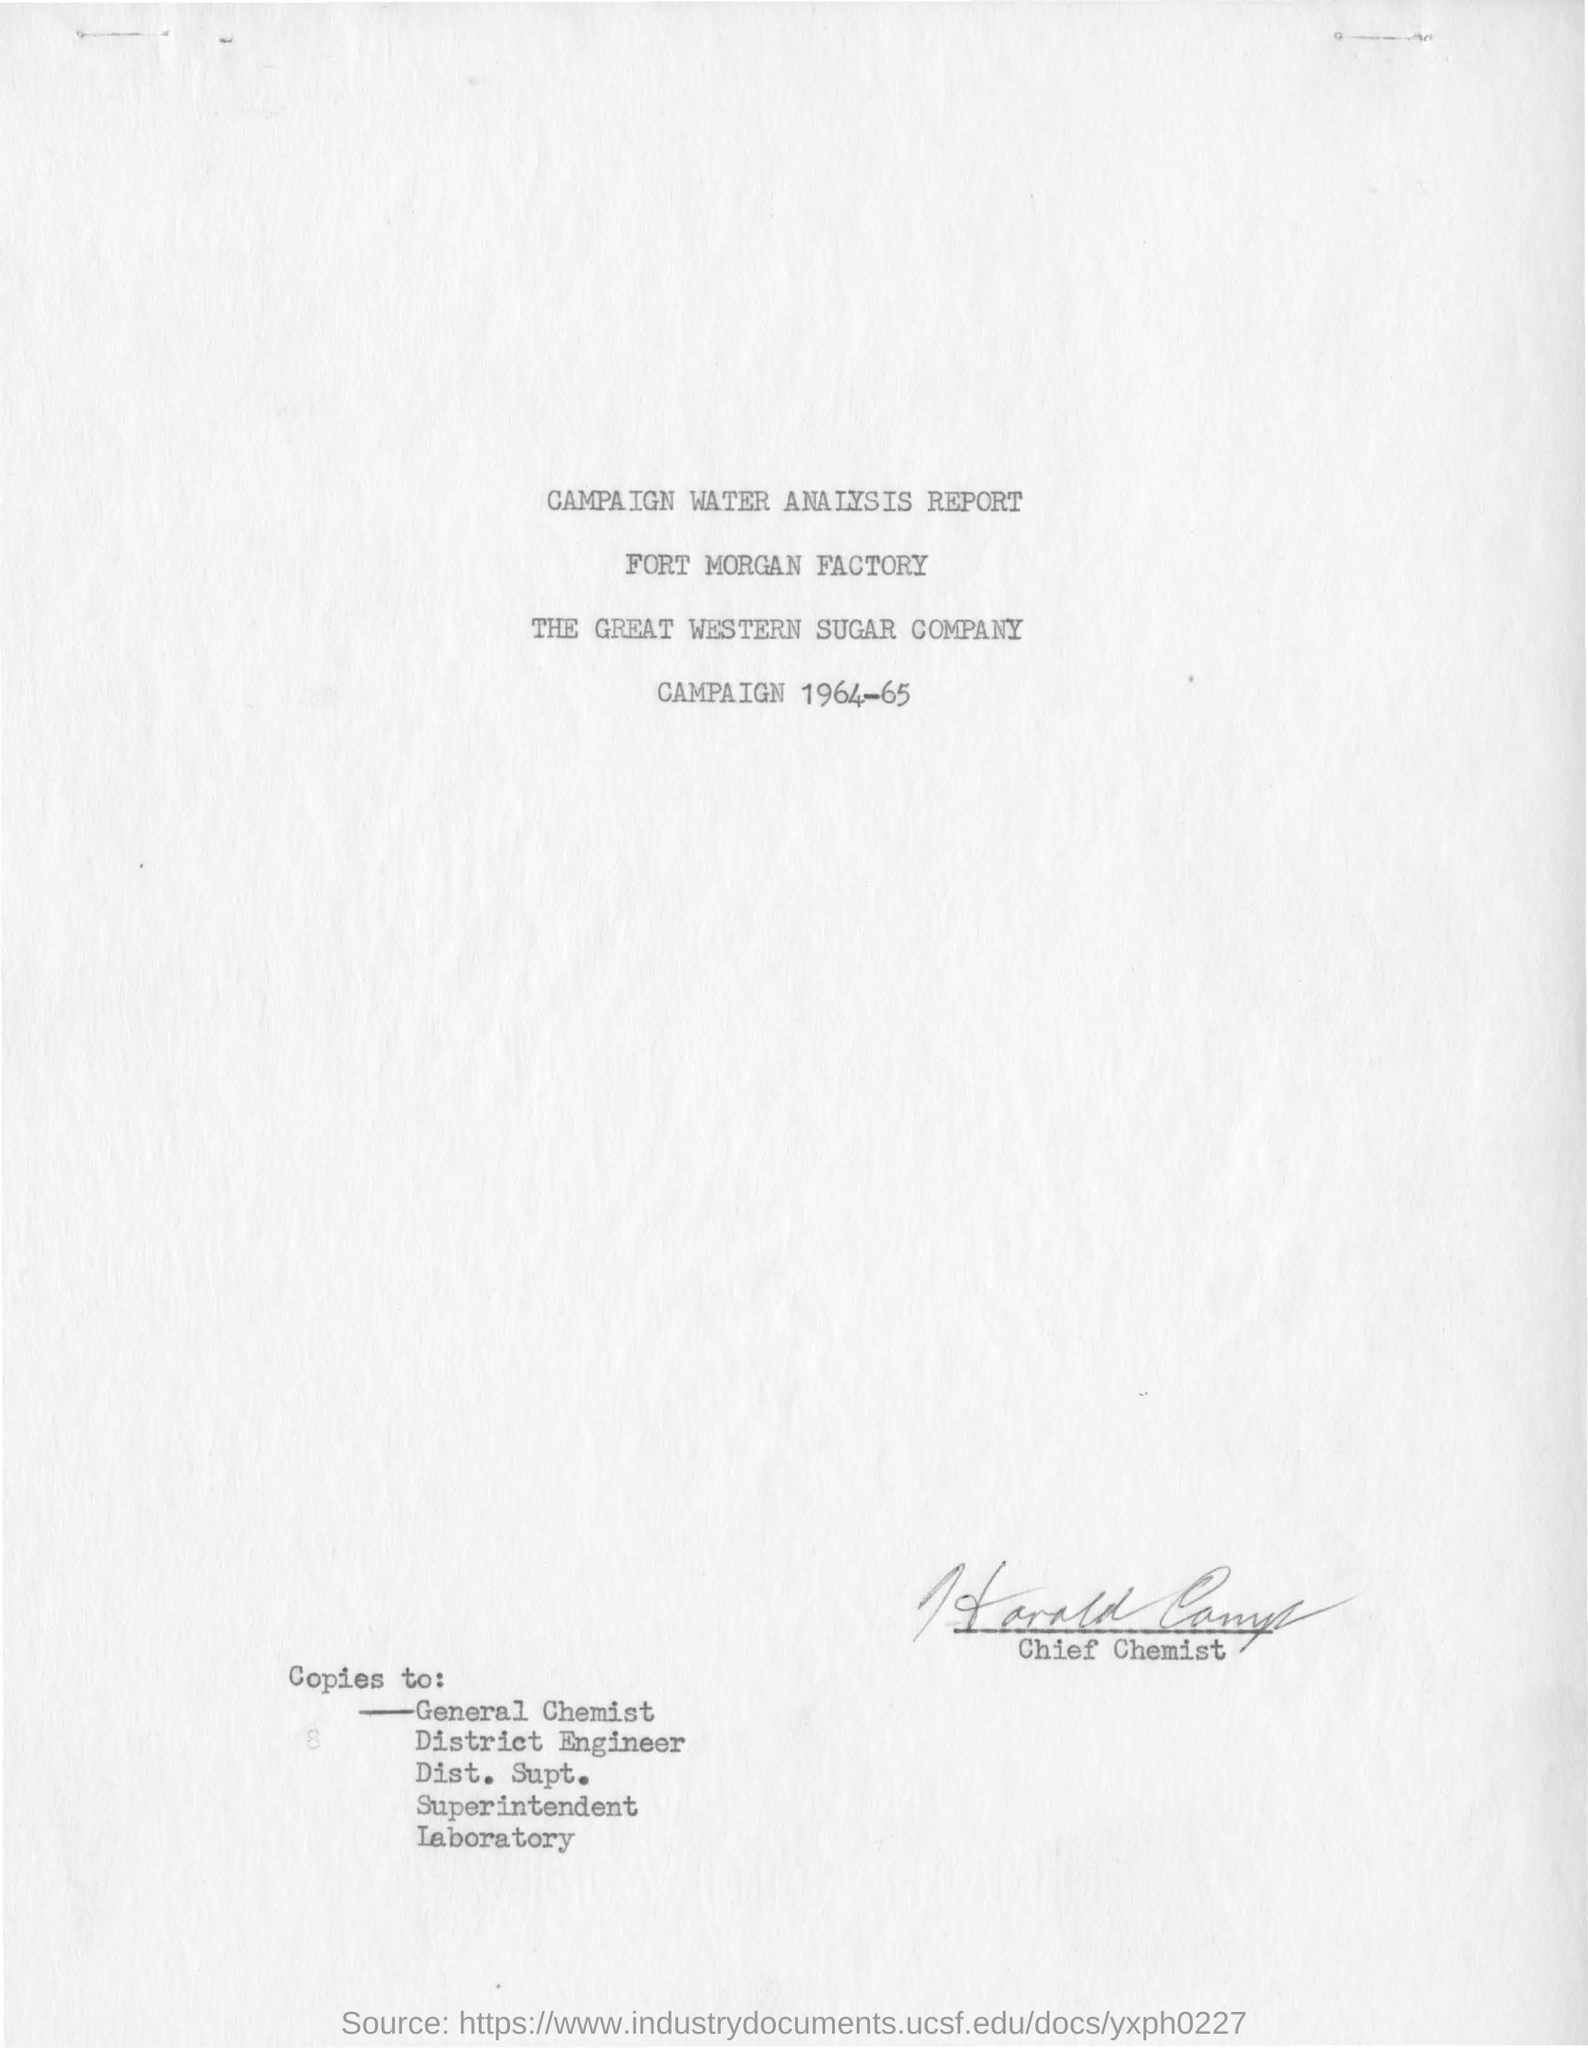Who has signed the report?
Your response must be concise. Chief Chemist. Which years' campaign report is this?
Your response must be concise. 1964-65. Which factory is mentioned in the campaign water analysis report?
Give a very brief answer. Fort Morgan Factory. 